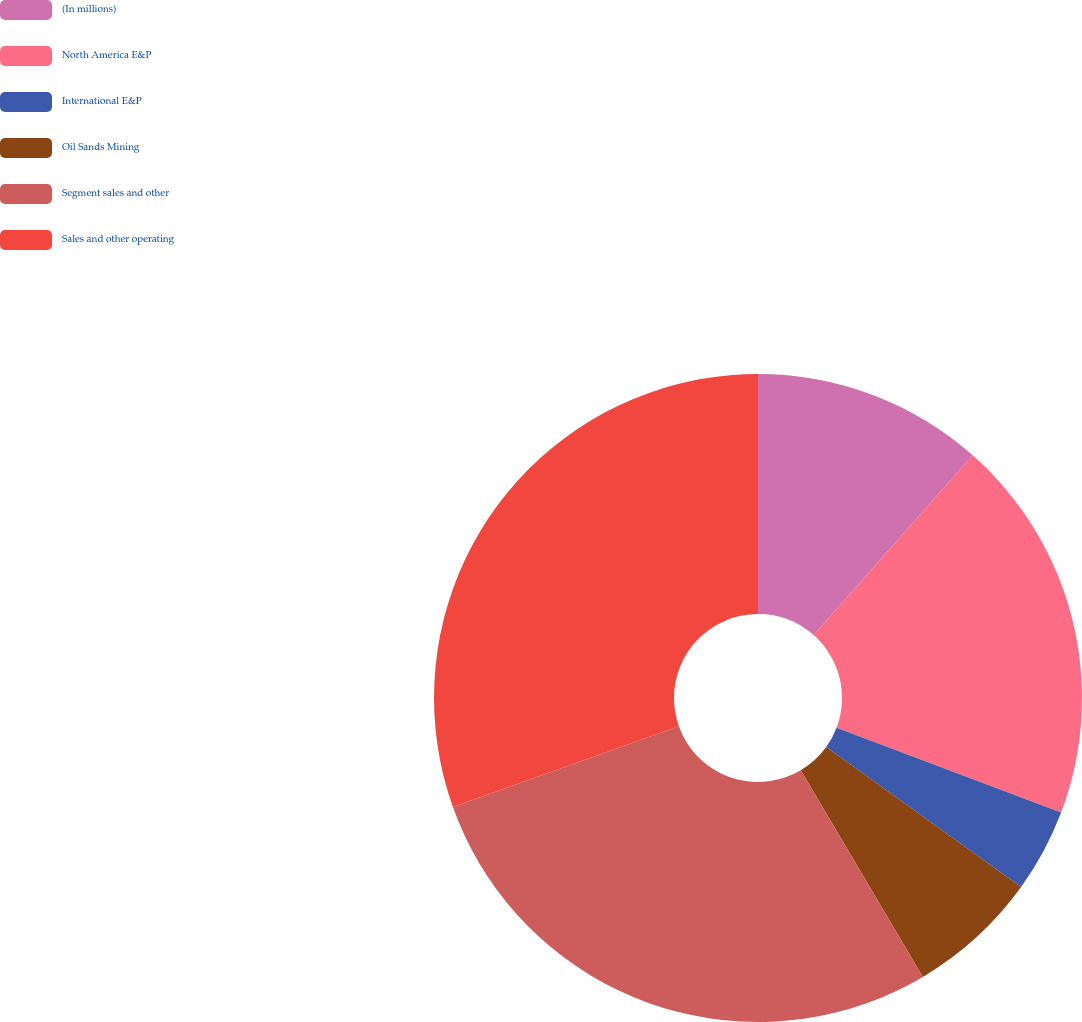Convert chart to OTSL. <chart><loc_0><loc_0><loc_500><loc_500><pie_chart><fcel>(In millions)<fcel>North America E&P<fcel>International E&P<fcel>Oil Sands Mining<fcel>Segment sales and other<fcel>Sales and other operating<nl><fcel>11.53%<fcel>19.22%<fcel>4.17%<fcel>6.58%<fcel>28.04%<fcel>30.46%<nl></chart> 